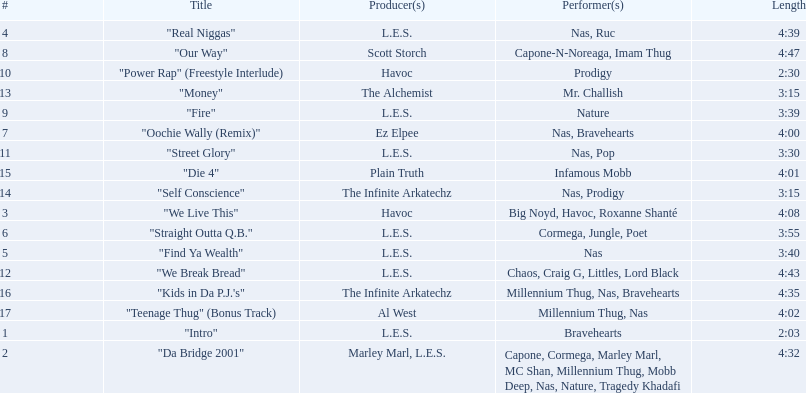What are the track times on the nas & ill will records presents qb's finest album? 2:03, 4:32, 4:08, 4:39, 3:40, 3:55, 4:00, 4:47, 3:39, 2:30, 3:30, 4:43, 3:15, 3:15, 4:01, 4:35, 4:02. Of those which is the longest? 4:47. 